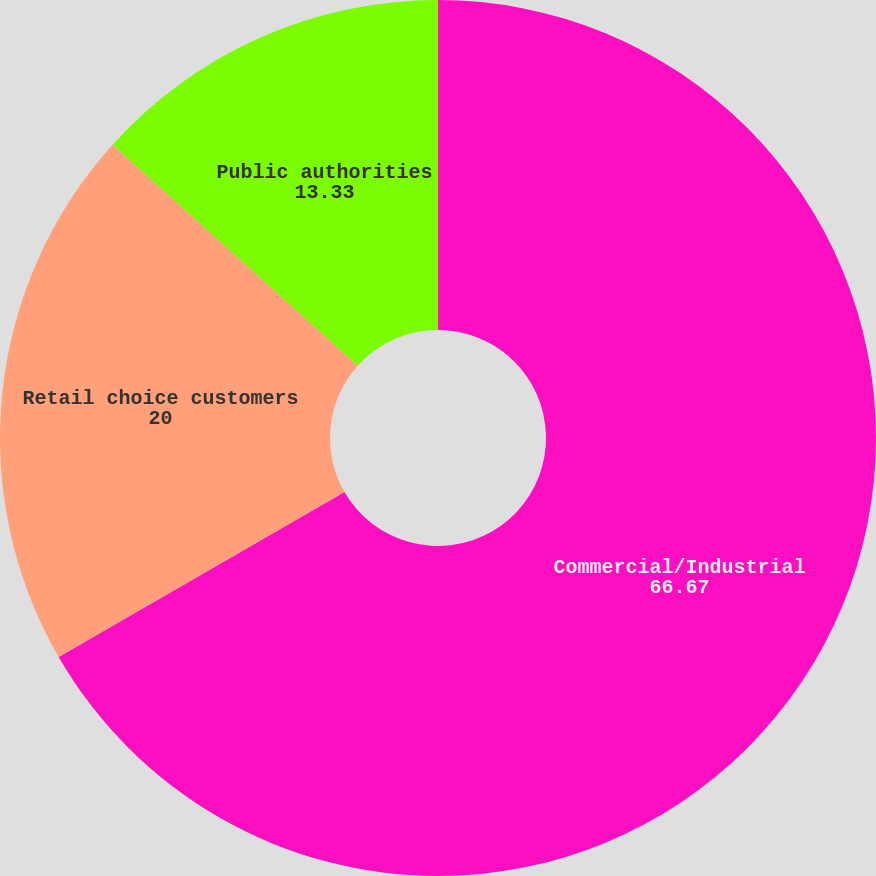Convert chart to OTSL. <chart><loc_0><loc_0><loc_500><loc_500><pie_chart><fcel>Commercial/Industrial<fcel>Retail choice customers<fcel>Public authorities<nl><fcel>66.67%<fcel>20.0%<fcel>13.33%<nl></chart> 